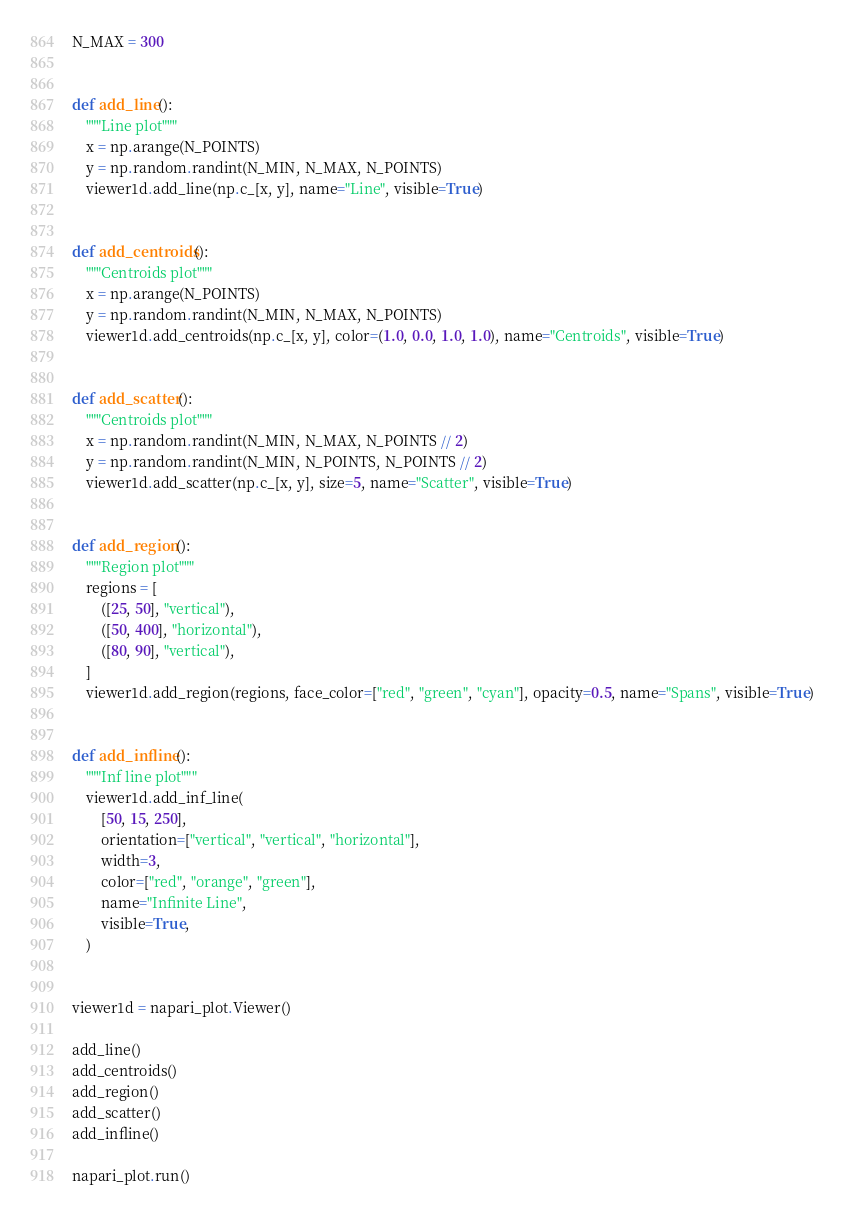Convert code to text. <code><loc_0><loc_0><loc_500><loc_500><_Python_>N_MAX = 300


def add_line():
    """Line plot"""
    x = np.arange(N_POINTS)
    y = np.random.randint(N_MIN, N_MAX, N_POINTS)
    viewer1d.add_line(np.c_[x, y], name="Line", visible=True)


def add_centroids():
    """Centroids plot"""
    x = np.arange(N_POINTS)
    y = np.random.randint(N_MIN, N_MAX, N_POINTS)
    viewer1d.add_centroids(np.c_[x, y], color=(1.0, 0.0, 1.0, 1.0), name="Centroids", visible=True)


def add_scatter():
    """Centroids plot"""
    x = np.random.randint(N_MIN, N_MAX, N_POINTS // 2)
    y = np.random.randint(N_MIN, N_POINTS, N_POINTS // 2)
    viewer1d.add_scatter(np.c_[x, y], size=5, name="Scatter", visible=True)


def add_region():
    """Region plot"""
    regions = [
        ([25, 50], "vertical"),
        ([50, 400], "horizontal"),
        ([80, 90], "vertical"),
    ]
    viewer1d.add_region(regions, face_color=["red", "green", "cyan"], opacity=0.5, name="Spans", visible=True)


def add_infline():
    """Inf line plot"""
    viewer1d.add_inf_line(
        [50, 15, 250],
        orientation=["vertical", "vertical", "horizontal"],
        width=3,
        color=["red", "orange", "green"],
        name="Infinite Line",
        visible=True,
    )


viewer1d = napari_plot.Viewer()

add_line()
add_centroids()
add_region()
add_scatter()
add_infline()

napari_plot.run()
</code> 